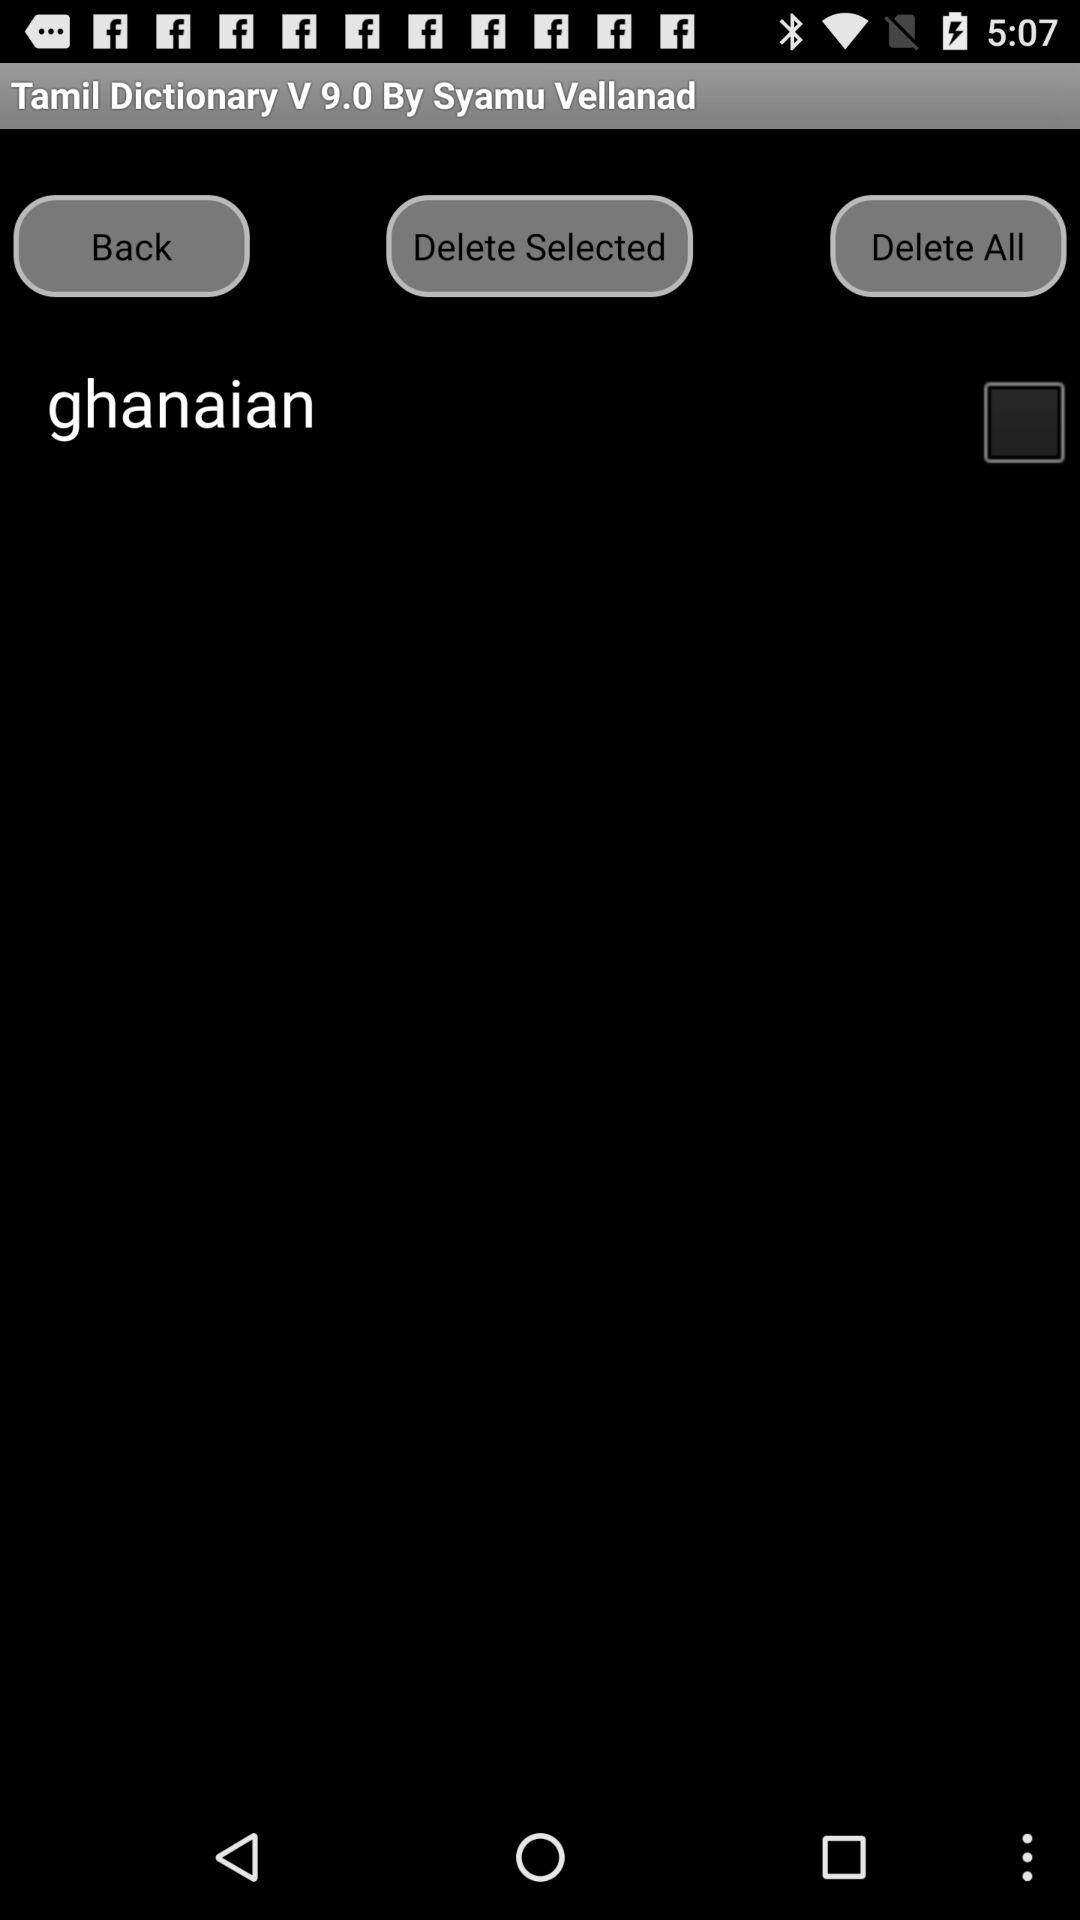What is the status of "ghanaian"? The status of "ghanaian" is "off". 